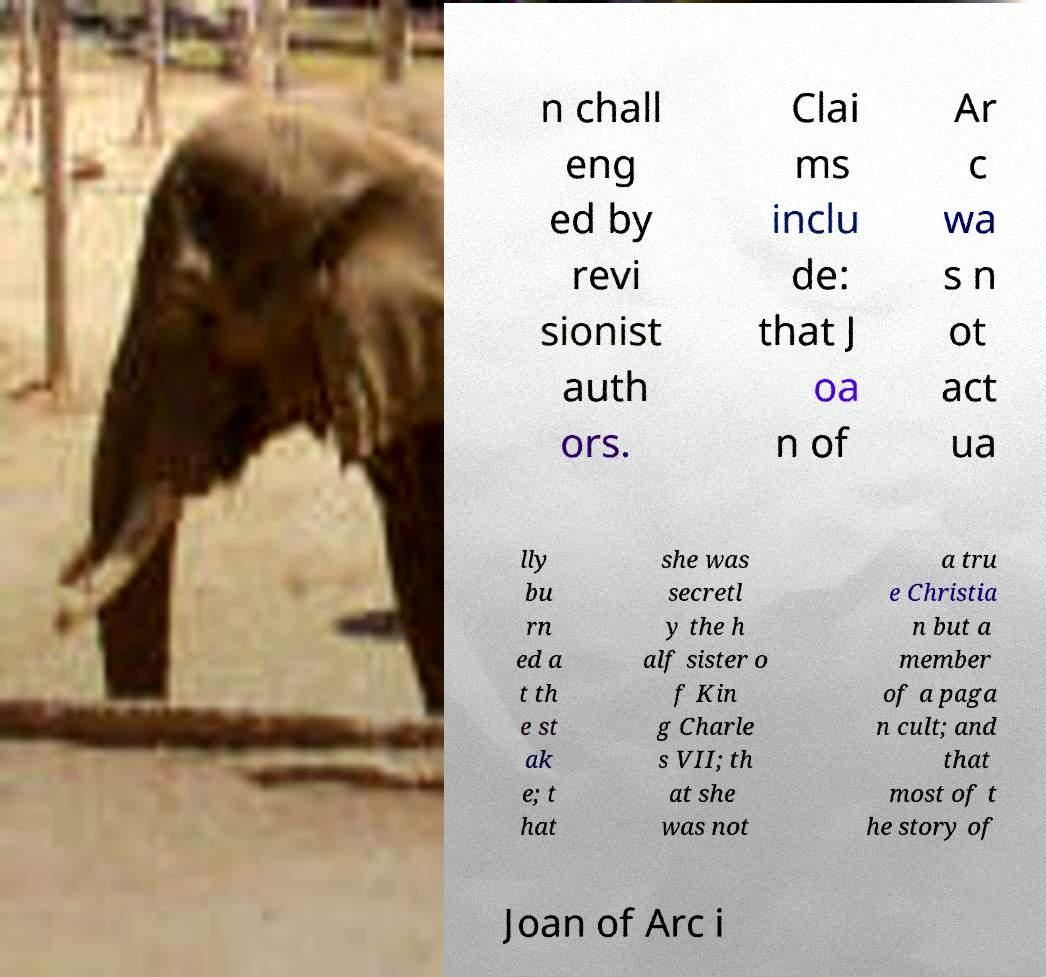Please identify and transcribe the text found in this image. n chall eng ed by revi sionist auth ors. Clai ms inclu de: that J oa n of Ar c wa s n ot act ua lly bu rn ed a t th e st ak e; t hat she was secretl y the h alf sister o f Kin g Charle s VII; th at she was not a tru e Christia n but a member of a paga n cult; and that most of t he story of Joan of Arc i 